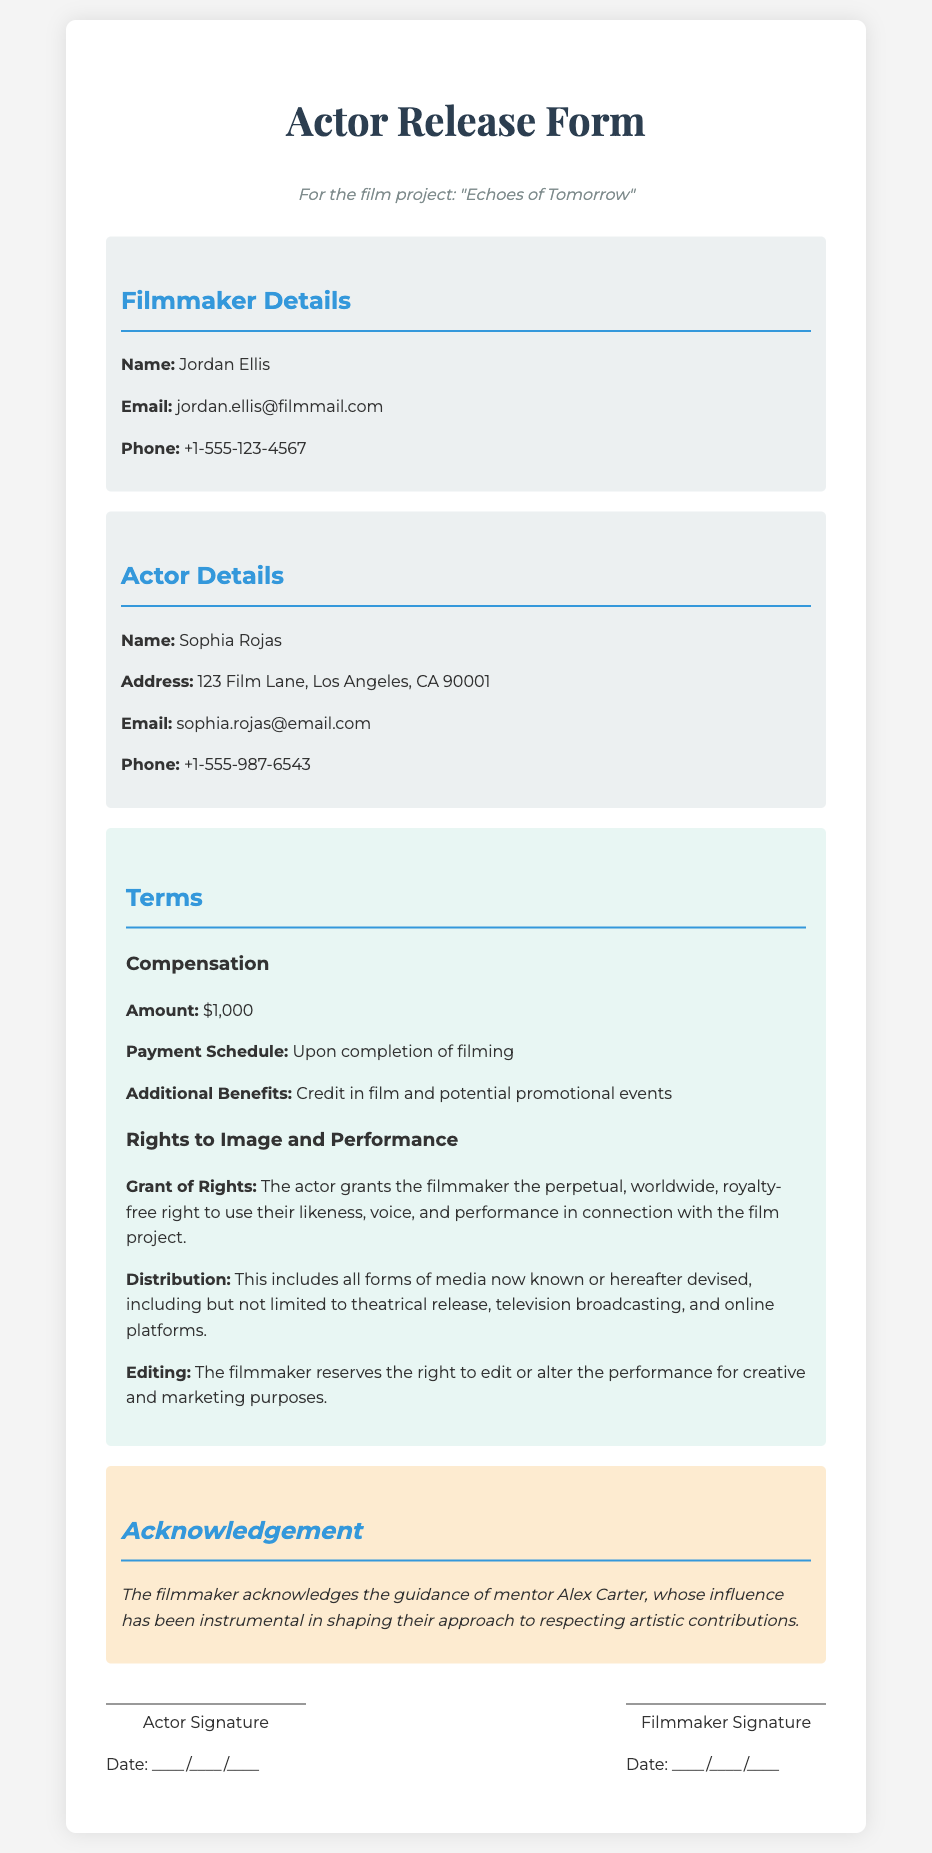What is the name of the filmmaker? The document lists the filmmaker's name as Jordan Ellis.
Answer: Jordan Ellis What is the film project title? The title of the film project is specified at the top of the document as "Echoes of Tomorrow."
Answer: Echoes of Tomorrow What is the compensation amount for the actor? The document states the compensation amount for the actor is $1,000.
Answer: $1,000 When will the payment be made? The payment schedule indicates payment will be made upon completion of filming.
Answer: Upon completion of filming What rights does the actor grant to the filmmaker? The document specifies that the actor grants the filmmaker a perpetual, worldwide, royalty-free right to use their likeness, voice, and performance.
Answer: Perpetual, worldwide, royalty-free right What is the additional benefit stated in the terms? The terms include that the actor will receive credit in the film and potential promotional events.
Answer: Credit in film and potential promotional events Who is acknowledged as a mentor in the document? The filmmaker acknowledges mentor Alex Carter in shaping their approach to respecting artistic contributions.
Answer: Alex Carter What type of document is this? The document is a release form specifically for actors participating in a film project.
Answer: Actor Release Form 